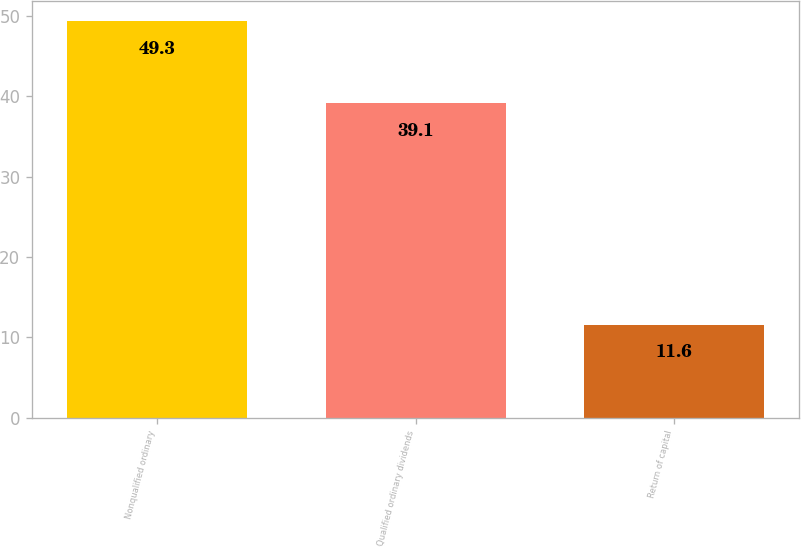<chart> <loc_0><loc_0><loc_500><loc_500><bar_chart><fcel>Nonqualified ordinary<fcel>Qualified ordinary dividends<fcel>Return of capital<nl><fcel>49.3<fcel>39.1<fcel>11.6<nl></chart> 